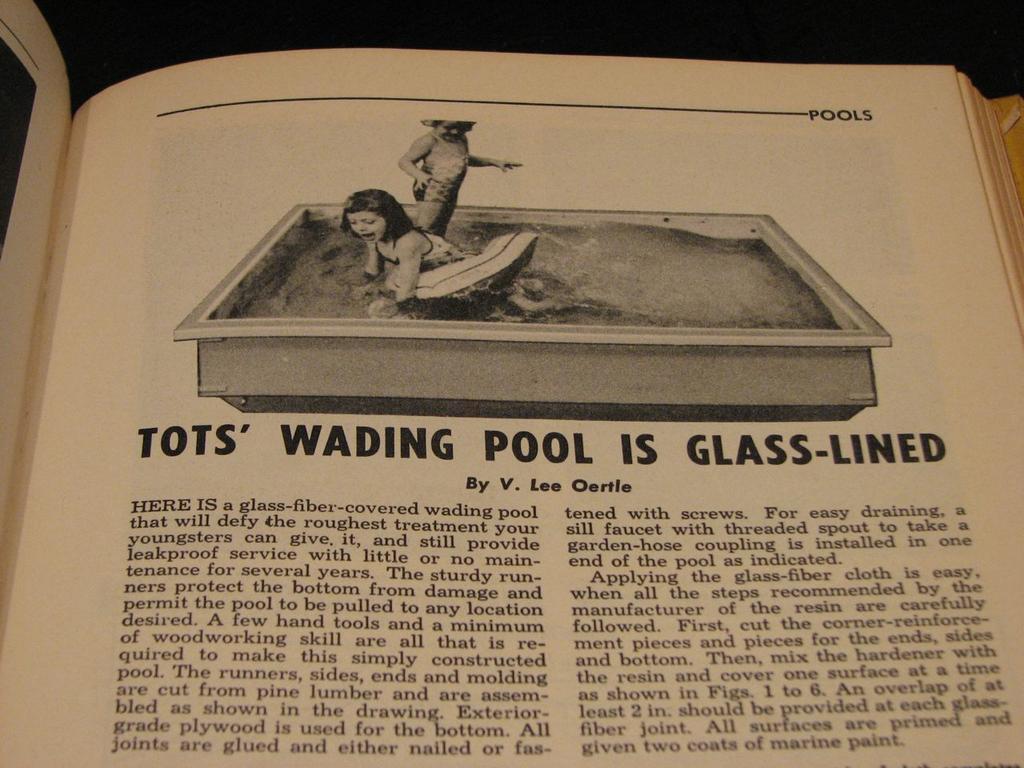Please provide a concise description of this image. In this picture we can see a paper with an image of two kids, water and a bathtub. On the paper, it is written something. Behind the paper, there is a dark background. 